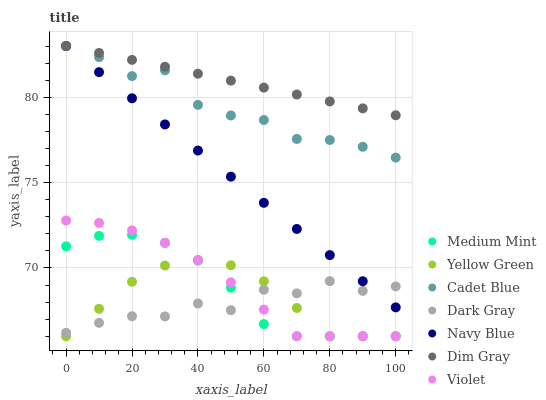Does Dark Gray have the minimum area under the curve?
Answer yes or no. Yes. Does Dim Gray have the maximum area under the curve?
Answer yes or no. Yes. Does Yellow Green have the minimum area under the curve?
Answer yes or no. No. Does Yellow Green have the maximum area under the curve?
Answer yes or no. No. Is Navy Blue the smoothest?
Answer yes or no. Yes. Is Dark Gray the roughest?
Answer yes or no. Yes. Is Dim Gray the smoothest?
Answer yes or no. No. Is Dim Gray the roughest?
Answer yes or no. No. Does Medium Mint have the lowest value?
Answer yes or no. Yes. Does Dim Gray have the lowest value?
Answer yes or no. No. Does Cadet Blue have the highest value?
Answer yes or no. Yes. Does Yellow Green have the highest value?
Answer yes or no. No. Is Yellow Green less than Cadet Blue?
Answer yes or no. Yes. Is Navy Blue greater than Violet?
Answer yes or no. Yes. Does Medium Mint intersect Dark Gray?
Answer yes or no. Yes. Is Medium Mint less than Dark Gray?
Answer yes or no. No. Is Medium Mint greater than Dark Gray?
Answer yes or no. No. Does Yellow Green intersect Cadet Blue?
Answer yes or no. No. 